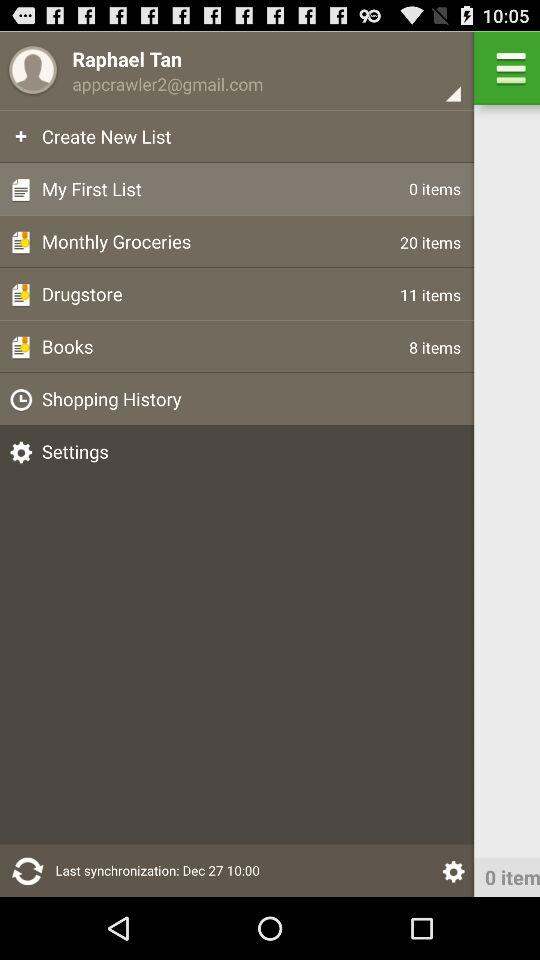How many items are in "My First list"? There are 0 items. 